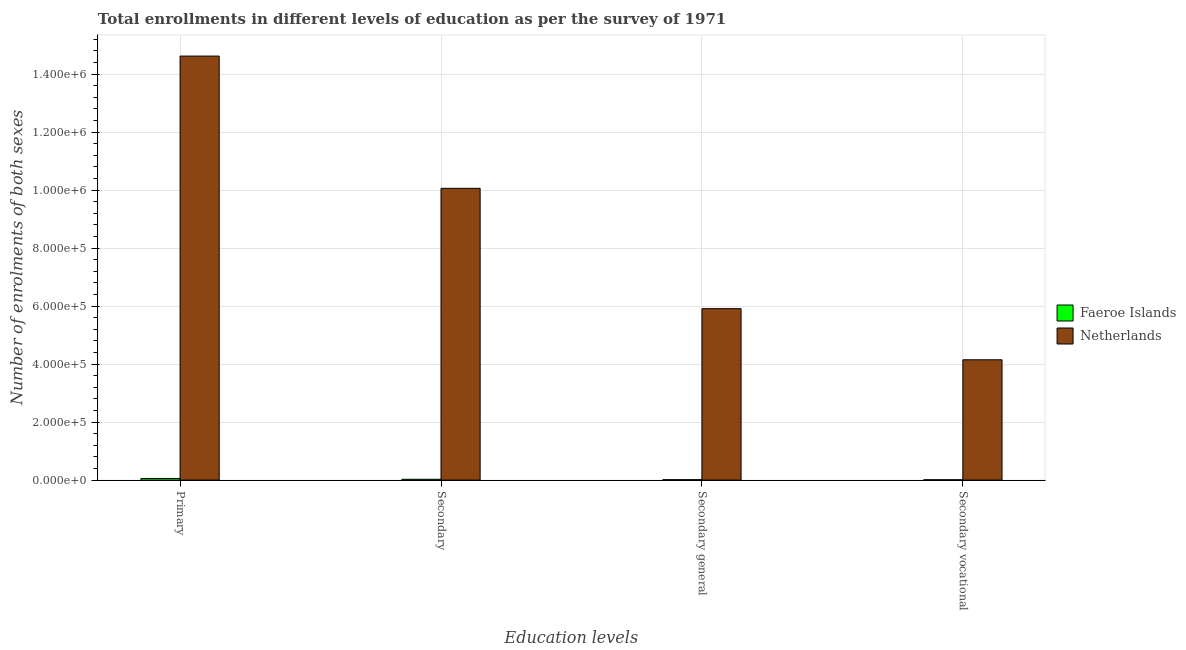How many groups of bars are there?
Ensure brevity in your answer.  4. Are the number of bars on each tick of the X-axis equal?
Give a very brief answer. Yes. How many bars are there on the 1st tick from the left?
Give a very brief answer. 2. What is the label of the 1st group of bars from the left?
Provide a short and direct response. Primary. What is the number of enrolments in secondary vocational education in Faeroe Islands?
Ensure brevity in your answer.  1212. Across all countries, what is the maximum number of enrolments in secondary vocational education?
Keep it short and to the point. 4.15e+05. Across all countries, what is the minimum number of enrolments in secondary education?
Make the answer very short. 2776. In which country was the number of enrolments in secondary vocational education minimum?
Offer a very short reply. Faeroe Islands. What is the total number of enrolments in primary education in the graph?
Your answer should be compact. 1.47e+06. What is the difference between the number of enrolments in primary education in Faeroe Islands and that in Netherlands?
Provide a short and direct response. -1.46e+06. What is the difference between the number of enrolments in primary education in Faeroe Islands and the number of enrolments in secondary education in Netherlands?
Provide a short and direct response. -1.00e+06. What is the average number of enrolments in primary education per country?
Your answer should be very brief. 7.34e+05. What is the difference between the number of enrolments in secondary vocational education and number of enrolments in secondary education in Netherlands?
Provide a short and direct response. -5.91e+05. What is the ratio of the number of enrolments in primary education in Faeroe Islands to that in Netherlands?
Offer a terse response. 0. Is the number of enrolments in secondary education in Netherlands less than that in Faeroe Islands?
Offer a very short reply. No. Is the difference between the number of enrolments in secondary general education in Netherlands and Faeroe Islands greater than the difference between the number of enrolments in secondary education in Netherlands and Faeroe Islands?
Offer a terse response. No. What is the difference between the highest and the second highest number of enrolments in secondary education?
Make the answer very short. 1.00e+06. What is the difference between the highest and the lowest number of enrolments in primary education?
Ensure brevity in your answer.  1.46e+06. In how many countries, is the number of enrolments in primary education greater than the average number of enrolments in primary education taken over all countries?
Your answer should be very brief. 1. Is the sum of the number of enrolments in secondary general education in Netherlands and Faeroe Islands greater than the maximum number of enrolments in secondary education across all countries?
Your answer should be very brief. No. What does the 1st bar from the left in Secondary vocational represents?
Provide a short and direct response. Faeroe Islands. What does the 2nd bar from the right in Secondary represents?
Make the answer very short. Faeroe Islands. Is it the case that in every country, the sum of the number of enrolments in primary education and number of enrolments in secondary education is greater than the number of enrolments in secondary general education?
Ensure brevity in your answer.  Yes. How many bars are there?
Your answer should be compact. 8. How many countries are there in the graph?
Provide a succinct answer. 2. Where does the legend appear in the graph?
Keep it short and to the point. Center right. How many legend labels are there?
Provide a short and direct response. 2. What is the title of the graph?
Provide a short and direct response. Total enrollments in different levels of education as per the survey of 1971. What is the label or title of the X-axis?
Your response must be concise. Education levels. What is the label or title of the Y-axis?
Make the answer very short. Number of enrolments of both sexes. What is the Number of enrolments of both sexes of Faeroe Islands in Primary?
Your response must be concise. 5539. What is the Number of enrolments of both sexes in Netherlands in Primary?
Provide a short and direct response. 1.46e+06. What is the Number of enrolments of both sexes in Faeroe Islands in Secondary?
Make the answer very short. 2776. What is the Number of enrolments of both sexes in Netherlands in Secondary?
Offer a very short reply. 1.01e+06. What is the Number of enrolments of both sexes in Faeroe Islands in Secondary general?
Your answer should be very brief. 1564. What is the Number of enrolments of both sexes of Netherlands in Secondary general?
Your response must be concise. 5.91e+05. What is the Number of enrolments of both sexes in Faeroe Islands in Secondary vocational?
Give a very brief answer. 1212. What is the Number of enrolments of both sexes of Netherlands in Secondary vocational?
Provide a short and direct response. 4.15e+05. Across all Education levels, what is the maximum Number of enrolments of both sexes in Faeroe Islands?
Offer a very short reply. 5539. Across all Education levels, what is the maximum Number of enrolments of both sexes of Netherlands?
Provide a short and direct response. 1.46e+06. Across all Education levels, what is the minimum Number of enrolments of both sexes of Faeroe Islands?
Ensure brevity in your answer.  1212. Across all Education levels, what is the minimum Number of enrolments of both sexes of Netherlands?
Provide a succinct answer. 4.15e+05. What is the total Number of enrolments of both sexes in Faeroe Islands in the graph?
Your answer should be very brief. 1.11e+04. What is the total Number of enrolments of both sexes in Netherlands in the graph?
Your answer should be very brief. 3.48e+06. What is the difference between the Number of enrolments of both sexes of Faeroe Islands in Primary and that in Secondary?
Make the answer very short. 2763. What is the difference between the Number of enrolments of both sexes of Netherlands in Primary and that in Secondary?
Keep it short and to the point. 4.56e+05. What is the difference between the Number of enrolments of both sexes of Faeroe Islands in Primary and that in Secondary general?
Your response must be concise. 3975. What is the difference between the Number of enrolments of both sexes in Netherlands in Primary and that in Secondary general?
Provide a succinct answer. 8.71e+05. What is the difference between the Number of enrolments of both sexes in Faeroe Islands in Primary and that in Secondary vocational?
Offer a very short reply. 4327. What is the difference between the Number of enrolments of both sexes of Netherlands in Primary and that in Secondary vocational?
Give a very brief answer. 1.05e+06. What is the difference between the Number of enrolments of both sexes in Faeroe Islands in Secondary and that in Secondary general?
Your answer should be compact. 1212. What is the difference between the Number of enrolments of both sexes of Netherlands in Secondary and that in Secondary general?
Give a very brief answer. 4.15e+05. What is the difference between the Number of enrolments of both sexes of Faeroe Islands in Secondary and that in Secondary vocational?
Your response must be concise. 1564. What is the difference between the Number of enrolments of both sexes of Netherlands in Secondary and that in Secondary vocational?
Your answer should be very brief. 5.91e+05. What is the difference between the Number of enrolments of both sexes in Faeroe Islands in Secondary general and that in Secondary vocational?
Ensure brevity in your answer.  352. What is the difference between the Number of enrolments of both sexes in Netherlands in Secondary general and that in Secondary vocational?
Provide a short and direct response. 1.76e+05. What is the difference between the Number of enrolments of both sexes in Faeroe Islands in Primary and the Number of enrolments of both sexes in Netherlands in Secondary?
Your response must be concise. -1.00e+06. What is the difference between the Number of enrolments of both sexes of Faeroe Islands in Primary and the Number of enrolments of both sexes of Netherlands in Secondary general?
Offer a terse response. -5.86e+05. What is the difference between the Number of enrolments of both sexes of Faeroe Islands in Primary and the Number of enrolments of both sexes of Netherlands in Secondary vocational?
Keep it short and to the point. -4.09e+05. What is the difference between the Number of enrolments of both sexes of Faeroe Islands in Secondary and the Number of enrolments of both sexes of Netherlands in Secondary general?
Keep it short and to the point. -5.89e+05. What is the difference between the Number of enrolments of both sexes in Faeroe Islands in Secondary and the Number of enrolments of both sexes in Netherlands in Secondary vocational?
Ensure brevity in your answer.  -4.12e+05. What is the difference between the Number of enrolments of both sexes in Faeroe Islands in Secondary general and the Number of enrolments of both sexes in Netherlands in Secondary vocational?
Ensure brevity in your answer.  -4.13e+05. What is the average Number of enrolments of both sexes in Faeroe Islands per Education levels?
Your answer should be compact. 2772.75. What is the average Number of enrolments of both sexes of Netherlands per Education levels?
Make the answer very short. 8.69e+05. What is the difference between the Number of enrolments of both sexes of Faeroe Islands and Number of enrolments of both sexes of Netherlands in Primary?
Offer a very short reply. -1.46e+06. What is the difference between the Number of enrolments of both sexes of Faeroe Islands and Number of enrolments of both sexes of Netherlands in Secondary?
Keep it short and to the point. -1.00e+06. What is the difference between the Number of enrolments of both sexes in Faeroe Islands and Number of enrolments of both sexes in Netherlands in Secondary general?
Keep it short and to the point. -5.90e+05. What is the difference between the Number of enrolments of both sexes of Faeroe Islands and Number of enrolments of both sexes of Netherlands in Secondary vocational?
Your answer should be very brief. -4.14e+05. What is the ratio of the Number of enrolments of both sexes in Faeroe Islands in Primary to that in Secondary?
Offer a terse response. 2. What is the ratio of the Number of enrolments of both sexes of Netherlands in Primary to that in Secondary?
Your response must be concise. 1.45. What is the ratio of the Number of enrolments of both sexes in Faeroe Islands in Primary to that in Secondary general?
Ensure brevity in your answer.  3.54. What is the ratio of the Number of enrolments of both sexes of Netherlands in Primary to that in Secondary general?
Offer a very short reply. 2.47. What is the ratio of the Number of enrolments of both sexes of Faeroe Islands in Primary to that in Secondary vocational?
Ensure brevity in your answer.  4.57. What is the ratio of the Number of enrolments of both sexes in Netherlands in Primary to that in Secondary vocational?
Keep it short and to the point. 3.52. What is the ratio of the Number of enrolments of both sexes of Faeroe Islands in Secondary to that in Secondary general?
Make the answer very short. 1.77. What is the ratio of the Number of enrolments of both sexes of Netherlands in Secondary to that in Secondary general?
Keep it short and to the point. 1.7. What is the ratio of the Number of enrolments of both sexes in Faeroe Islands in Secondary to that in Secondary vocational?
Your response must be concise. 2.29. What is the ratio of the Number of enrolments of both sexes of Netherlands in Secondary to that in Secondary vocational?
Your answer should be very brief. 2.42. What is the ratio of the Number of enrolments of both sexes in Faeroe Islands in Secondary general to that in Secondary vocational?
Keep it short and to the point. 1.29. What is the ratio of the Number of enrolments of both sexes in Netherlands in Secondary general to that in Secondary vocational?
Offer a terse response. 1.42. What is the difference between the highest and the second highest Number of enrolments of both sexes in Faeroe Islands?
Provide a short and direct response. 2763. What is the difference between the highest and the second highest Number of enrolments of both sexes in Netherlands?
Offer a very short reply. 4.56e+05. What is the difference between the highest and the lowest Number of enrolments of both sexes in Faeroe Islands?
Your answer should be very brief. 4327. What is the difference between the highest and the lowest Number of enrolments of both sexes of Netherlands?
Provide a short and direct response. 1.05e+06. 